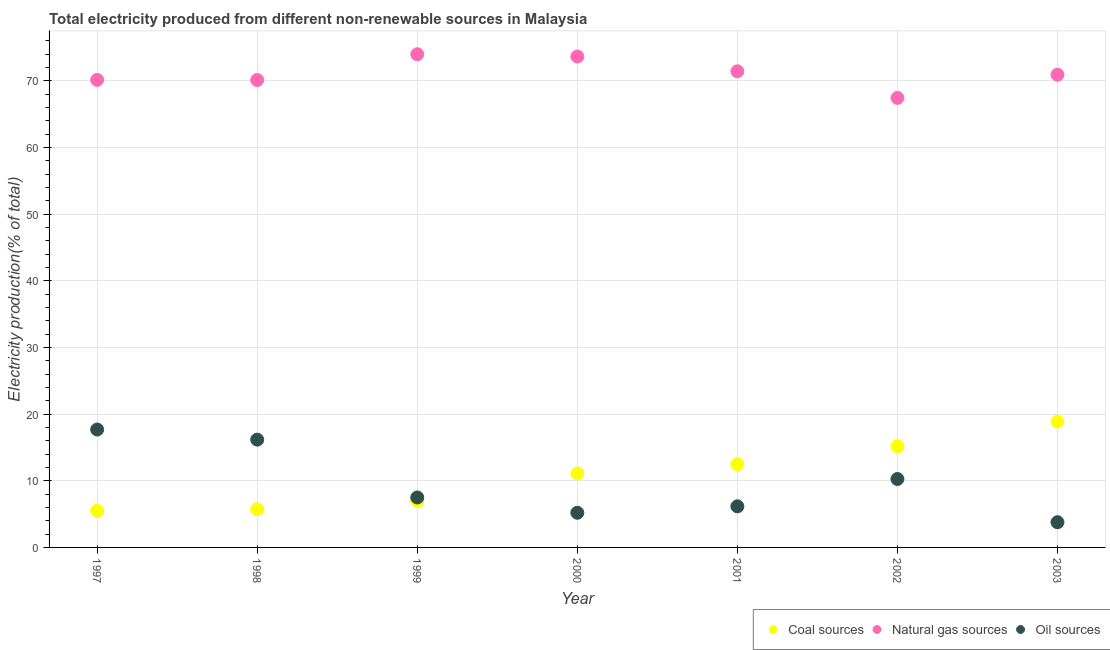How many different coloured dotlines are there?
Offer a very short reply. 3. Is the number of dotlines equal to the number of legend labels?
Provide a succinct answer. Yes. What is the percentage of electricity produced by natural gas in 2002?
Your answer should be very brief. 67.42. Across all years, what is the maximum percentage of electricity produced by natural gas?
Give a very brief answer. 73.98. Across all years, what is the minimum percentage of electricity produced by natural gas?
Your answer should be compact. 67.42. In which year was the percentage of electricity produced by natural gas minimum?
Offer a terse response. 2002. What is the total percentage of electricity produced by coal in the graph?
Make the answer very short. 75.84. What is the difference between the percentage of electricity produced by natural gas in 2001 and that in 2002?
Make the answer very short. 4. What is the difference between the percentage of electricity produced by coal in 2002 and the percentage of electricity produced by natural gas in 1998?
Offer a terse response. -54.94. What is the average percentage of electricity produced by natural gas per year?
Provide a short and direct response. 71.09. In the year 1998, what is the difference between the percentage of electricity produced by coal and percentage of electricity produced by oil sources?
Offer a very short reply. -10.44. What is the ratio of the percentage of electricity produced by natural gas in 1999 to that in 2001?
Offer a very short reply. 1.04. What is the difference between the highest and the second highest percentage of electricity produced by oil sources?
Offer a very short reply. 1.51. What is the difference between the highest and the lowest percentage of electricity produced by coal?
Offer a very short reply. 13.38. In how many years, is the percentage of electricity produced by oil sources greater than the average percentage of electricity produced by oil sources taken over all years?
Your response must be concise. 3. Does the percentage of electricity produced by natural gas monotonically increase over the years?
Make the answer very short. No. Is the percentage of electricity produced by coal strictly greater than the percentage of electricity produced by oil sources over the years?
Provide a succinct answer. No. Does the graph contain grids?
Your response must be concise. Yes. Where does the legend appear in the graph?
Your answer should be very brief. Bottom right. How many legend labels are there?
Your answer should be compact. 3. How are the legend labels stacked?
Your answer should be compact. Horizontal. What is the title of the graph?
Give a very brief answer. Total electricity produced from different non-renewable sources in Malaysia. Does "Agriculture" appear as one of the legend labels in the graph?
Provide a succinct answer. No. What is the label or title of the X-axis?
Provide a short and direct response. Year. What is the label or title of the Y-axis?
Your response must be concise. Electricity production(% of total). What is the Electricity production(% of total) of Coal sources in 1997?
Offer a very short reply. 5.49. What is the Electricity production(% of total) of Natural gas sources in 1997?
Your response must be concise. 70.13. What is the Electricity production(% of total) in Oil sources in 1997?
Your answer should be compact. 17.68. What is the Electricity production(% of total) in Coal sources in 1998?
Your answer should be very brief. 5.72. What is the Electricity production(% of total) in Natural gas sources in 1998?
Offer a terse response. 70.11. What is the Electricity production(% of total) of Oil sources in 1998?
Your answer should be very brief. 16.17. What is the Electricity production(% of total) in Coal sources in 1999?
Keep it short and to the point. 6.99. What is the Electricity production(% of total) in Natural gas sources in 1999?
Offer a terse response. 73.98. What is the Electricity production(% of total) of Oil sources in 1999?
Make the answer very short. 7.49. What is the Electricity production(% of total) of Coal sources in 2000?
Offer a terse response. 11.11. What is the Electricity production(% of total) of Natural gas sources in 2000?
Make the answer very short. 73.64. What is the Electricity production(% of total) in Oil sources in 2000?
Your answer should be compact. 5.2. What is the Electricity production(% of total) of Coal sources in 2001?
Your answer should be very brief. 12.49. What is the Electricity production(% of total) of Natural gas sources in 2001?
Give a very brief answer. 71.42. What is the Electricity production(% of total) of Oil sources in 2001?
Your response must be concise. 6.16. What is the Electricity production(% of total) of Coal sources in 2002?
Offer a terse response. 15.17. What is the Electricity production(% of total) in Natural gas sources in 2002?
Offer a very short reply. 67.42. What is the Electricity production(% of total) in Oil sources in 2002?
Provide a succinct answer. 10.26. What is the Electricity production(% of total) of Coal sources in 2003?
Provide a short and direct response. 18.87. What is the Electricity production(% of total) in Natural gas sources in 2003?
Your answer should be very brief. 70.9. What is the Electricity production(% of total) of Oil sources in 2003?
Offer a very short reply. 3.78. Across all years, what is the maximum Electricity production(% of total) in Coal sources?
Your response must be concise. 18.87. Across all years, what is the maximum Electricity production(% of total) in Natural gas sources?
Your answer should be very brief. 73.98. Across all years, what is the maximum Electricity production(% of total) of Oil sources?
Offer a terse response. 17.68. Across all years, what is the minimum Electricity production(% of total) of Coal sources?
Provide a succinct answer. 5.49. Across all years, what is the minimum Electricity production(% of total) in Natural gas sources?
Your response must be concise. 67.42. Across all years, what is the minimum Electricity production(% of total) in Oil sources?
Make the answer very short. 3.78. What is the total Electricity production(% of total) in Coal sources in the graph?
Your answer should be very brief. 75.84. What is the total Electricity production(% of total) in Natural gas sources in the graph?
Offer a terse response. 497.61. What is the total Electricity production(% of total) of Oil sources in the graph?
Ensure brevity in your answer.  66.75. What is the difference between the Electricity production(% of total) in Coal sources in 1997 and that in 1998?
Offer a very short reply. -0.23. What is the difference between the Electricity production(% of total) in Natural gas sources in 1997 and that in 1998?
Make the answer very short. 0.02. What is the difference between the Electricity production(% of total) of Oil sources in 1997 and that in 1998?
Keep it short and to the point. 1.51. What is the difference between the Electricity production(% of total) of Coal sources in 1997 and that in 1999?
Keep it short and to the point. -1.5. What is the difference between the Electricity production(% of total) in Natural gas sources in 1997 and that in 1999?
Your answer should be compact. -3.85. What is the difference between the Electricity production(% of total) in Oil sources in 1997 and that in 1999?
Provide a short and direct response. 10.19. What is the difference between the Electricity production(% of total) of Coal sources in 1997 and that in 2000?
Your response must be concise. -5.61. What is the difference between the Electricity production(% of total) in Natural gas sources in 1997 and that in 2000?
Your answer should be compact. -3.51. What is the difference between the Electricity production(% of total) in Oil sources in 1997 and that in 2000?
Provide a succinct answer. 12.48. What is the difference between the Electricity production(% of total) of Coal sources in 1997 and that in 2001?
Keep it short and to the point. -6.99. What is the difference between the Electricity production(% of total) of Natural gas sources in 1997 and that in 2001?
Provide a succinct answer. -1.29. What is the difference between the Electricity production(% of total) in Oil sources in 1997 and that in 2001?
Keep it short and to the point. 11.52. What is the difference between the Electricity production(% of total) of Coal sources in 1997 and that in 2002?
Offer a very short reply. -9.67. What is the difference between the Electricity production(% of total) in Natural gas sources in 1997 and that in 2002?
Ensure brevity in your answer.  2.71. What is the difference between the Electricity production(% of total) of Oil sources in 1997 and that in 2002?
Provide a short and direct response. 7.42. What is the difference between the Electricity production(% of total) of Coal sources in 1997 and that in 2003?
Offer a very short reply. -13.38. What is the difference between the Electricity production(% of total) of Natural gas sources in 1997 and that in 2003?
Your answer should be compact. -0.77. What is the difference between the Electricity production(% of total) in Oil sources in 1997 and that in 2003?
Ensure brevity in your answer.  13.9. What is the difference between the Electricity production(% of total) in Coal sources in 1998 and that in 1999?
Provide a succinct answer. -1.27. What is the difference between the Electricity production(% of total) of Natural gas sources in 1998 and that in 1999?
Provide a succinct answer. -3.87. What is the difference between the Electricity production(% of total) in Oil sources in 1998 and that in 1999?
Your answer should be very brief. 8.68. What is the difference between the Electricity production(% of total) in Coal sources in 1998 and that in 2000?
Your response must be concise. -5.38. What is the difference between the Electricity production(% of total) of Natural gas sources in 1998 and that in 2000?
Give a very brief answer. -3.53. What is the difference between the Electricity production(% of total) in Oil sources in 1998 and that in 2000?
Offer a terse response. 10.97. What is the difference between the Electricity production(% of total) of Coal sources in 1998 and that in 2001?
Keep it short and to the point. -6.76. What is the difference between the Electricity production(% of total) in Natural gas sources in 1998 and that in 2001?
Keep it short and to the point. -1.31. What is the difference between the Electricity production(% of total) of Oil sources in 1998 and that in 2001?
Offer a terse response. 10. What is the difference between the Electricity production(% of total) of Coal sources in 1998 and that in 2002?
Offer a very short reply. -9.44. What is the difference between the Electricity production(% of total) of Natural gas sources in 1998 and that in 2002?
Your response must be concise. 2.69. What is the difference between the Electricity production(% of total) of Oil sources in 1998 and that in 2002?
Give a very brief answer. 5.91. What is the difference between the Electricity production(% of total) in Coal sources in 1998 and that in 2003?
Make the answer very short. -13.15. What is the difference between the Electricity production(% of total) in Natural gas sources in 1998 and that in 2003?
Your answer should be compact. -0.79. What is the difference between the Electricity production(% of total) of Oil sources in 1998 and that in 2003?
Provide a short and direct response. 12.39. What is the difference between the Electricity production(% of total) of Coal sources in 1999 and that in 2000?
Offer a very short reply. -4.12. What is the difference between the Electricity production(% of total) in Natural gas sources in 1999 and that in 2000?
Provide a succinct answer. 0.34. What is the difference between the Electricity production(% of total) in Oil sources in 1999 and that in 2000?
Provide a short and direct response. 2.29. What is the difference between the Electricity production(% of total) in Coal sources in 1999 and that in 2001?
Your response must be concise. -5.49. What is the difference between the Electricity production(% of total) of Natural gas sources in 1999 and that in 2001?
Your answer should be compact. 2.56. What is the difference between the Electricity production(% of total) in Oil sources in 1999 and that in 2001?
Offer a terse response. 1.33. What is the difference between the Electricity production(% of total) of Coal sources in 1999 and that in 2002?
Keep it short and to the point. -8.18. What is the difference between the Electricity production(% of total) of Natural gas sources in 1999 and that in 2002?
Provide a succinct answer. 6.56. What is the difference between the Electricity production(% of total) in Oil sources in 1999 and that in 2002?
Offer a terse response. -2.77. What is the difference between the Electricity production(% of total) in Coal sources in 1999 and that in 2003?
Your answer should be compact. -11.88. What is the difference between the Electricity production(% of total) in Natural gas sources in 1999 and that in 2003?
Make the answer very short. 3.08. What is the difference between the Electricity production(% of total) of Oil sources in 1999 and that in 2003?
Offer a very short reply. 3.71. What is the difference between the Electricity production(% of total) in Coal sources in 2000 and that in 2001?
Make the answer very short. -1.38. What is the difference between the Electricity production(% of total) of Natural gas sources in 2000 and that in 2001?
Your answer should be compact. 2.22. What is the difference between the Electricity production(% of total) in Oil sources in 2000 and that in 2001?
Your answer should be compact. -0.97. What is the difference between the Electricity production(% of total) of Coal sources in 2000 and that in 2002?
Offer a very short reply. -4.06. What is the difference between the Electricity production(% of total) of Natural gas sources in 2000 and that in 2002?
Provide a succinct answer. 6.21. What is the difference between the Electricity production(% of total) in Oil sources in 2000 and that in 2002?
Your response must be concise. -5.06. What is the difference between the Electricity production(% of total) of Coal sources in 2000 and that in 2003?
Your answer should be compact. -7.77. What is the difference between the Electricity production(% of total) in Natural gas sources in 2000 and that in 2003?
Provide a short and direct response. 2.73. What is the difference between the Electricity production(% of total) in Oil sources in 2000 and that in 2003?
Keep it short and to the point. 1.42. What is the difference between the Electricity production(% of total) in Coal sources in 2001 and that in 2002?
Make the answer very short. -2.68. What is the difference between the Electricity production(% of total) of Natural gas sources in 2001 and that in 2002?
Offer a terse response. 4. What is the difference between the Electricity production(% of total) of Oil sources in 2001 and that in 2002?
Make the answer very short. -4.1. What is the difference between the Electricity production(% of total) of Coal sources in 2001 and that in 2003?
Ensure brevity in your answer.  -6.39. What is the difference between the Electricity production(% of total) of Natural gas sources in 2001 and that in 2003?
Your answer should be very brief. 0.52. What is the difference between the Electricity production(% of total) in Oil sources in 2001 and that in 2003?
Your answer should be very brief. 2.38. What is the difference between the Electricity production(% of total) in Coal sources in 2002 and that in 2003?
Offer a very short reply. -3.7. What is the difference between the Electricity production(% of total) of Natural gas sources in 2002 and that in 2003?
Keep it short and to the point. -3.48. What is the difference between the Electricity production(% of total) of Oil sources in 2002 and that in 2003?
Keep it short and to the point. 6.48. What is the difference between the Electricity production(% of total) of Coal sources in 1997 and the Electricity production(% of total) of Natural gas sources in 1998?
Your response must be concise. -64.62. What is the difference between the Electricity production(% of total) in Coal sources in 1997 and the Electricity production(% of total) in Oil sources in 1998?
Make the answer very short. -10.67. What is the difference between the Electricity production(% of total) of Natural gas sources in 1997 and the Electricity production(% of total) of Oil sources in 1998?
Keep it short and to the point. 53.96. What is the difference between the Electricity production(% of total) in Coal sources in 1997 and the Electricity production(% of total) in Natural gas sources in 1999?
Offer a terse response. -68.49. What is the difference between the Electricity production(% of total) of Coal sources in 1997 and the Electricity production(% of total) of Oil sources in 1999?
Give a very brief answer. -2. What is the difference between the Electricity production(% of total) in Natural gas sources in 1997 and the Electricity production(% of total) in Oil sources in 1999?
Give a very brief answer. 62.64. What is the difference between the Electricity production(% of total) of Coal sources in 1997 and the Electricity production(% of total) of Natural gas sources in 2000?
Provide a succinct answer. -68.14. What is the difference between the Electricity production(% of total) in Coal sources in 1997 and the Electricity production(% of total) in Oil sources in 2000?
Your answer should be compact. 0.3. What is the difference between the Electricity production(% of total) in Natural gas sources in 1997 and the Electricity production(% of total) in Oil sources in 2000?
Keep it short and to the point. 64.93. What is the difference between the Electricity production(% of total) in Coal sources in 1997 and the Electricity production(% of total) in Natural gas sources in 2001?
Keep it short and to the point. -65.93. What is the difference between the Electricity production(% of total) of Coal sources in 1997 and the Electricity production(% of total) of Oil sources in 2001?
Offer a terse response. -0.67. What is the difference between the Electricity production(% of total) of Natural gas sources in 1997 and the Electricity production(% of total) of Oil sources in 2001?
Your answer should be compact. 63.97. What is the difference between the Electricity production(% of total) of Coal sources in 1997 and the Electricity production(% of total) of Natural gas sources in 2002?
Provide a succinct answer. -61.93. What is the difference between the Electricity production(% of total) in Coal sources in 1997 and the Electricity production(% of total) in Oil sources in 2002?
Keep it short and to the point. -4.77. What is the difference between the Electricity production(% of total) of Natural gas sources in 1997 and the Electricity production(% of total) of Oil sources in 2002?
Ensure brevity in your answer.  59.87. What is the difference between the Electricity production(% of total) of Coal sources in 1997 and the Electricity production(% of total) of Natural gas sources in 2003?
Your answer should be compact. -65.41. What is the difference between the Electricity production(% of total) of Coal sources in 1997 and the Electricity production(% of total) of Oil sources in 2003?
Your answer should be compact. 1.71. What is the difference between the Electricity production(% of total) of Natural gas sources in 1997 and the Electricity production(% of total) of Oil sources in 2003?
Your answer should be very brief. 66.35. What is the difference between the Electricity production(% of total) in Coal sources in 1998 and the Electricity production(% of total) in Natural gas sources in 1999?
Offer a terse response. -68.26. What is the difference between the Electricity production(% of total) in Coal sources in 1998 and the Electricity production(% of total) in Oil sources in 1999?
Provide a short and direct response. -1.77. What is the difference between the Electricity production(% of total) of Natural gas sources in 1998 and the Electricity production(% of total) of Oil sources in 1999?
Provide a succinct answer. 62.62. What is the difference between the Electricity production(% of total) of Coal sources in 1998 and the Electricity production(% of total) of Natural gas sources in 2000?
Your answer should be very brief. -67.91. What is the difference between the Electricity production(% of total) in Coal sources in 1998 and the Electricity production(% of total) in Oil sources in 2000?
Provide a short and direct response. 0.53. What is the difference between the Electricity production(% of total) in Natural gas sources in 1998 and the Electricity production(% of total) in Oil sources in 2000?
Provide a short and direct response. 64.91. What is the difference between the Electricity production(% of total) in Coal sources in 1998 and the Electricity production(% of total) in Natural gas sources in 2001?
Your answer should be very brief. -65.7. What is the difference between the Electricity production(% of total) of Coal sources in 1998 and the Electricity production(% of total) of Oil sources in 2001?
Keep it short and to the point. -0.44. What is the difference between the Electricity production(% of total) in Natural gas sources in 1998 and the Electricity production(% of total) in Oil sources in 2001?
Your answer should be compact. 63.95. What is the difference between the Electricity production(% of total) in Coal sources in 1998 and the Electricity production(% of total) in Natural gas sources in 2002?
Make the answer very short. -61.7. What is the difference between the Electricity production(% of total) in Coal sources in 1998 and the Electricity production(% of total) in Oil sources in 2002?
Give a very brief answer. -4.54. What is the difference between the Electricity production(% of total) in Natural gas sources in 1998 and the Electricity production(% of total) in Oil sources in 2002?
Give a very brief answer. 59.85. What is the difference between the Electricity production(% of total) in Coal sources in 1998 and the Electricity production(% of total) in Natural gas sources in 2003?
Give a very brief answer. -65.18. What is the difference between the Electricity production(% of total) of Coal sources in 1998 and the Electricity production(% of total) of Oil sources in 2003?
Provide a short and direct response. 1.94. What is the difference between the Electricity production(% of total) of Natural gas sources in 1998 and the Electricity production(% of total) of Oil sources in 2003?
Your response must be concise. 66.33. What is the difference between the Electricity production(% of total) of Coal sources in 1999 and the Electricity production(% of total) of Natural gas sources in 2000?
Ensure brevity in your answer.  -66.65. What is the difference between the Electricity production(% of total) of Coal sources in 1999 and the Electricity production(% of total) of Oil sources in 2000?
Offer a very short reply. 1.79. What is the difference between the Electricity production(% of total) in Natural gas sources in 1999 and the Electricity production(% of total) in Oil sources in 2000?
Your answer should be compact. 68.78. What is the difference between the Electricity production(% of total) of Coal sources in 1999 and the Electricity production(% of total) of Natural gas sources in 2001?
Your answer should be very brief. -64.43. What is the difference between the Electricity production(% of total) in Coal sources in 1999 and the Electricity production(% of total) in Oil sources in 2001?
Make the answer very short. 0.83. What is the difference between the Electricity production(% of total) of Natural gas sources in 1999 and the Electricity production(% of total) of Oil sources in 2001?
Ensure brevity in your answer.  67.82. What is the difference between the Electricity production(% of total) of Coal sources in 1999 and the Electricity production(% of total) of Natural gas sources in 2002?
Keep it short and to the point. -60.43. What is the difference between the Electricity production(% of total) in Coal sources in 1999 and the Electricity production(% of total) in Oil sources in 2002?
Your response must be concise. -3.27. What is the difference between the Electricity production(% of total) of Natural gas sources in 1999 and the Electricity production(% of total) of Oil sources in 2002?
Provide a succinct answer. 63.72. What is the difference between the Electricity production(% of total) of Coal sources in 1999 and the Electricity production(% of total) of Natural gas sources in 2003?
Your answer should be compact. -63.91. What is the difference between the Electricity production(% of total) of Coal sources in 1999 and the Electricity production(% of total) of Oil sources in 2003?
Provide a succinct answer. 3.21. What is the difference between the Electricity production(% of total) in Natural gas sources in 1999 and the Electricity production(% of total) in Oil sources in 2003?
Offer a terse response. 70.2. What is the difference between the Electricity production(% of total) in Coal sources in 2000 and the Electricity production(% of total) in Natural gas sources in 2001?
Offer a terse response. -60.32. What is the difference between the Electricity production(% of total) of Coal sources in 2000 and the Electricity production(% of total) of Oil sources in 2001?
Keep it short and to the point. 4.94. What is the difference between the Electricity production(% of total) of Natural gas sources in 2000 and the Electricity production(% of total) of Oil sources in 2001?
Give a very brief answer. 67.47. What is the difference between the Electricity production(% of total) of Coal sources in 2000 and the Electricity production(% of total) of Natural gas sources in 2002?
Your response must be concise. -56.32. What is the difference between the Electricity production(% of total) in Coal sources in 2000 and the Electricity production(% of total) in Oil sources in 2002?
Your answer should be very brief. 0.84. What is the difference between the Electricity production(% of total) in Natural gas sources in 2000 and the Electricity production(% of total) in Oil sources in 2002?
Your answer should be compact. 63.38. What is the difference between the Electricity production(% of total) of Coal sources in 2000 and the Electricity production(% of total) of Natural gas sources in 2003?
Provide a short and direct response. -59.8. What is the difference between the Electricity production(% of total) in Coal sources in 2000 and the Electricity production(% of total) in Oil sources in 2003?
Provide a short and direct response. 7.32. What is the difference between the Electricity production(% of total) of Natural gas sources in 2000 and the Electricity production(% of total) of Oil sources in 2003?
Ensure brevity in your answer.  69.86. What is the difference between the Electricity production(% of total) in Coal sources in 2001 and the Electricity production(% of total) in Natural gas sources in 2002?
Provide a succinct answer. -54.94. What is the difference between the Electricity production(% of total) of Coal sources in 2001 and the Electricity production(% of total) of Oil sources in 2002?
Make the answer very short. 2.22. What is the difference between the Electricity production(% of total) in Natural gas sources in 2001 and the Electricity production(% of total) in Oil sources in 2002?
Ensure brevity in your answer.  61.16. What is the difference between the Electricity production(% of total) in Coal sources in 2001 and the Electricity production(% of total) in Natural gas sources in 2003?
Your answer should be compact. -58.42. What is the difference between the Electricity production(% of total) of Coal sources in 2001 and the Electricity production(% of total) of Oil sources in 2003?
Offer a terse response. 8.7. What is the difference between the Electricity production(% of total) in Natural gas sources in 2001 and the Electricity production(% of total) in Oil sources in 2003?
Your answer should be very brief. 67.64. What is the difference between the Electricity production(% of total) of Coal sources in 2002 and the Electricity production(% of total) of Natural gas sources in 2003?
Provide a succinct answer. -55.74. What is the difference between the Electricity production(% of total) in Coal sources in 2002 and the Electricity production(% of total) in Oil sources in 2003?
Provide a succinct answer. 11.39. What is the difference between the Electricity production(% of total) in Natural gas sources in 2002 and the Electricity production(% of total) in Oil sources in 2003?
Give a very brief answer. 63.64. What is the average Electricity production(% of total) in Coal sources per year?
Ensure brevity in your answer.  10.83. What is the average Electricity production(% of total) of Natural gas sources per year?
Make the answer very short. 71.09. What is the average Electricity production(% of total) of Oil sources per year?
Keep it short and to the point. 9.54. In the year 1997, what is the difference between the Electricity production(% of total) in Coal sources and Electricity production(% of total) in Natural gas sources?
Give a very brief answer. -64.64. In the year 1997, what is the difference between the Electricity production(% of total) in Coal sources and Electricity production(% of total) in Oil sources?
Your answer should be compact. -12.19. In the year 1997, what is the difference between the Electricity production(% of total) in Natural gas sources and Electricity production(% of total) in Oil sources?
Provide a succinct answer. 52.45. In the year 1998, what is the difference between the Electricity production(% of total) of Coal sources and Electricity production(% of total) of Natural gas sources?
Provide a succinct answer. -64.39. In the year 1998, what is the difference between the Electricity production(% of total) in Coal sources and Electricity production(% of total) in Oil sources?
Give a very brief answer. -10.44. In the year 1998, what is the difference between the Electricity production(% of total) in Natural gas sources and Electricity production(% of total) in Oil sources?
Offer a terse response. 53.94. In the year 1999, what is the difference between the Electricity production(% of total) of Coal sources and Electricity production(% of total) of Natural gas sources?
Give a very brief answer. -66.99. In the year 1999, what is the difference between the Electricity production(% of total) of Coal sources and Electricity production(% of total) of Oil sources?
Your answer should be very brief. -0.5. In the year 1999, what is the difference between the Electricity production(% of total) in Natural gas sources and Electricity production(% of total) in Oil sources?
Offer a terse response. 66.49. In the year 2000, what is the difference between the Electricity production(% of total) of Coal sources and Electricity production(% of total) of Natural gas sources?
Provide a succinct answer. -62.53. In the year 2000, what is the difference between the Electricity production(% of total) of Coal sources and Electricity production(% of total) of Oil sources?
Make the answer very short. 5.91. In the year 2000, what is the difference between the Electricity production(% of total) of Natural gas sources and Electricity production(% of total) of Oil sources?
Your answer should be compact. 68.44. In the year 2001, what is the difference between the Electricity production(% of total) of Coal sources and Electricity production(% of total) of Natural gas sources?
Make the answer very short. -58.94. In the year 2001, what is the difference between the Electricity production(% of total) in Coal sources and Electricity production(% of total) in Oil sources?
Offer a terse response. 6.32. In the year 2001, what is the difference between the Electricity production(% of total) in Natural gas sources and Electricity production(% of total) in Oil sources?
Ensure brevity in your answer.  65.26. In the year 2002, what is the difference between the Electricity production(% of total) in Coal sources and Electricity production(% of total) in Natural gas sources?
Keep it short and to the point. -52.26. In the year 2002, what is the difference between the Electricity production(% of total) of Coal sources and Electricity production(% of total) of Oil sources?
Provide a short and direct response. 4.91. In the year 2002, what is the difference between the Electricity production(% of total) of Natural gas sources and Electricity production(% of total) of Oil sources?
Ensure brevity in your answer.  57.16. In the year 2003, what is the difference between the Electricity production(% of total) in Coal sources and Electricity production(% of total) in Natural gas sources?
Offer a terse response. -52.03. In the year 2003, what is the difference between the Electricity production(% of total) of Coal sources and Electricity production(% of total) of Oil sources?
Give a very brief answer. 15.09. In the year 2003, what is the difference between the Electricity production(% of total) in Natural gas sources and Electricity production(% of total) in Oil sources?
Offer a terse response. 67.12. What is the ratio of the Electricity production(% of total) in Coal sources in 1997 to that in 1998?
Provide a succinct answer. 0.96. What is the ratio of the Electricity production(% of total) of Oil sources in 1997 to that in 1998?
Ensure brevity in your answer.  1.09. What is the ratio of the Electricity production(% of total) of Coal sources in 1997 to that in 1999?
Your response must be concise. 0.79. What is the ratio of the Electricity production(% of total) in Natural gas sources in 1997 to that in 1999?
Ensure brevity in your answer.  0.95. What is the ratio of the Electricity production(% of total) in Oil sources in 1997 to that in 1999?
Offer a very short reply. 2.36. What is the ratio of the Electricity production(% of total) of Coal sources in 1997 to that in 2000?
Your response must be concise. 0.49. What is the ratio of the Electricity production(% of total) in Oil sources in 1997 to that in 2000?
Your response must be concise. 3.4. What is the ratio of the Electricity production(% of total) in Coal sources in 1997 to that in 2001?
Offer a very short reply. 0.44. What is the ratio of the Electricity production(% of total) of Oil sources in 1997 to that in 2001?
Your answer should be very brief. 2.87. What is the ratio of the Electricity production(% of total) in Coal sources in 1997 to that in 2002?
Ensure brevity in your answer.  0.36. What is the ratio of the Electricity production(% of total) of Natural gas sources in 1997 to that in 2002?
Give a very brief answer. 1.04. What is the ratio of the Electricity production(% of total) in Oil sources in 1997 to that in 2002?
Offer a very short reply. 1.72. What is the ratio of the Electricity production(% of total) of Coal sources in 1997 to that in 2003?
Your response must be concise. 0.29. What is the ratio of the Electricity production(% of total) of Natural gas sources in 1997 to that in 2003?
Your answer should be compact. 0.99. What is the ratio of the Electricity production(% of total) of Oil sources in 1997 to that in 2003?
Make the answer very short. 4.67. What is the ratio of the Electricity production(% of total) in Coal sources in 1998 to that in 1999?
Ensure brevity in your answer.  0.82. What is the ratio of the Electricity production(% of total) in Natural gas sources in 1998 to that in 1999?
Your answer should be compact. 0.95. What is the ratio of the Electricity production(% of total) of Oil sources in 1998 to that in 1999?
Offer a terse response. 2.16. What is the ratio of the Electricity production(% of total) of Coal sources in 1998 to that in 2000?
Give a very brief answer. 0.52. What is the ratio of the Electricity production(% of total) in Natural gas sources in 1998 to that in 2000?
Provide a succinct answer. 0.95. What is the ratio of the Electricity production(% of total) of Oil sources in 1998 to that in 2000?
Ensure brevity in your answer.  3.11. What is the ratio of the Electricity production(% of total) of Coal sources in 1998 to that in 2001?
Offer a very short reply. 0.46. What is the ratio of the Electricity production(% of total) of Natural gas sources in 1998 to that in 2001?
Your answer should be very brief. 0.98. What is the ratio of the Electricity production(% of total) of Oil sources in 1998 to that in 2001?
Provide a short and direct response. 2.62. What is the ratio of the Electricity production(% of total) of Coal sources in 1998 to that in 2002?
Your response must be concise. 0.38. What is the ratio of the Electricity production(% of total) of Natural gas sources in 1998 to that in 2002?
Your response must be concise. 1.04. What is the ratio of the Electricity production(% of total) of Oil sources in 1998 to that in 2002?
Your answer should be compact. 1.58. What is the ratio of the Electricity production(% of total) of Coal sources in 1998 to that in 2003?
Your answer should be very brief. 0.3. What is the ratio of the Electricity production(% of total) in Natural gas sources in 1998 to that in 2003?
Provide a succinct answer. 0.99. What is the ratio of the Electricity production(% of total) of Oil sources in 1998 to that in 2003?
Give a very brief answer. 4.27. What is the ratio of the Electricity production(% of total) of Coal sources in 1999 to that in 2000?
Provide a succinct answer. 0.63. What is the ratio of the Electricity production(% of total) in Natural gas sources in 1999 to that in 2000?
Offer a very short reply. 1. What is the ratio of the Electricity production(% of total) of Oil sources in 1999 to that in 2000?
Offer a very short reply. 1.44. What is the ratio of the Electricity production(% of total) in Coal sources in 1999 to that in 2001?
Provide a short and direct response. 0.56. What is the ratio of the Electricity production(% of total) of Natural gas sources in 1999 to that in 2001?
Keep it short and to the point. 1.04. What is the ratio of the Electricity production(% of total) of Oil sources in 1999 to that in 2001?
Your response must be concise. 1.22. What is the ratio of the Electricity production(% of total) of Coal sources in 1999 to that in 2002?
Offer a very short reply. 0.46. What is the ratio of the Electricity production(% of total) in Natural gas sources in 1999 to that in 2002?
Provide a succinct answer. 1.1. What is the ratio of the Electricity production(% of total) in Oil sources in 1999 to that in 2002?
Offer a very short reply. 0.73. What is the ratio of the Electricity production(% of total) of Coal sources in 1999 to that in 2003?
Provide a short and direct response. 0.37. What is the ratio of the Electricity production(% of total) in Natural gas sources in 1999 to that in 2003?
Offer a very short reply. 1.04. What is the ratio of the Electricity production(% of total) in Oil sources in 1999 to that in 2003?
Ensure brevity in your answer.  1.98. What is the ratio of the Electricity production(% of total) of Coal sources in 2000 to that in 2001?
Provide a short and direct response. 0.89. What is the ratio of the Electricity production(% of total) in Natural gas sources in 2000 to that in 2001?
Offer a terse response. 1.03. What is the ratio of the Electricity production(% of total) in Oil sources in 2000 to that in 2001?
Your answer should be compact. 0.84. What is the ratio of the Electricity production(% of total) of Coal sources in 2000 to that in 2002?
Your answer should be compact. 0.73. What is the ratio of the Electricity production(% of total) of Natural gas sources in 2000 to that in 2002?
Provide a succinct answer. 1.09. What is the ratio of the Electricity production(% of total) in Oil sources in 2000 to that in 2002?
Ensure brevity in your answer.  0.51. What is the ratio of the Electricity production(% of total) in Coal sources in 2000 to that in 2003?
Ensure brevity in your answer.  0.59. What is the ratio of the Electricity production(% of total) in Natural gas sources in 2000 to that in 2003?
Make the answer very short. 1.04. What is the ratio of the Electricity production(% of total) of Oil sources in 2000 to that in 2003?
Your response must be concise. 1.37. What is the ratio of the Electricity production(% of total) in Coal sources in 2001 to that in 2002?
Your answer should be compact. 0.82. What is the ratio of the Electricity production(% of total) in Natural gas sources in 2001 to that in 2002?
Give a very brief answer. 1.06. What is the ratio of the Electricity production(% of total) in Oil sources in 2001 to that in 2002?
Provide a short and direct response. 0.6. What is the ratio of the Electricity production(% of total) of Coal sources in 2001 to that in 2003?
Make the answer very short. 0.66. What is the ratio of the Electricity production(% of total) in Natural gas sources in 2001 to that in 2003?
Offer a very short reply. 1.01. What is the ratio of the Electricity production(% of total) of Oil sources in 2001 to that in 2003?
Provide a short and direct response. 1.63. What is the ratio of the Electricity production(% of total) in Coal sources in 2002 to that in 2003?
Your answer should be compact. 0.8. What is the ratio of the Electricity production(% of total) of Natural gas sources in 2002 to that in 2003?
Ensure brevity in your answer.  0.95. What is the ratio of the Electricity production(% of total) in Oil sources in 2002 to that in 2003?
Offer a terse response. 2.71. What is the difference between the highest and the second highest Electricity production(% of total) in Coal sources?
Your response must be concise. 3.7. What is the difference between the highest and the second highest Electricity production(% of total) in Natural gas sources?
Ensure brevity in your answer.  0.34. What is the difference between the highest and the second highest Electricity production(% of total) of Oil sources?
Offer a very short reply. 1.51. What is the difference between the highest and the lowest Electricity production(% of total) in Coal sources?
Give a very brief answer. 13.38. What is the difference between the highest and the lowest Electricity production(% of total) in Natural gas sources?
Make the answer very short. 6.56. What is the difference between the highest and the lowest Electricity production(% of total) of Oil sources?
Give a very brief answer. 13.9. 